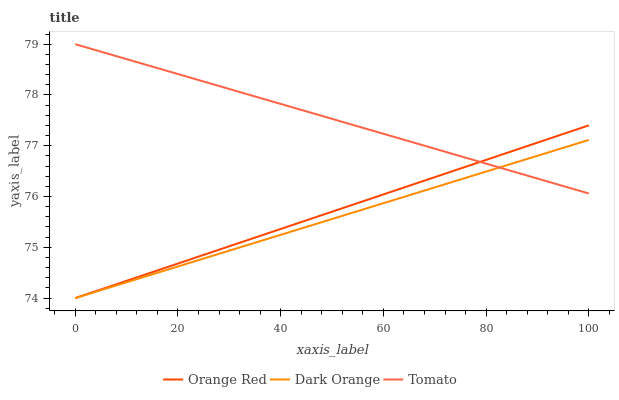Does Orange Red have the minimum area under the curve?
Answer yes or no. No. Does Orange Red have the maximum area under the curve?
Answer yes or no. No. Is Orange Red the smoothest?
Answer yes or no. No. Is Orange Red the roughest?
Answer yes or no. No. Does Orange Red have the highest value?
Answer yes or no. No. 